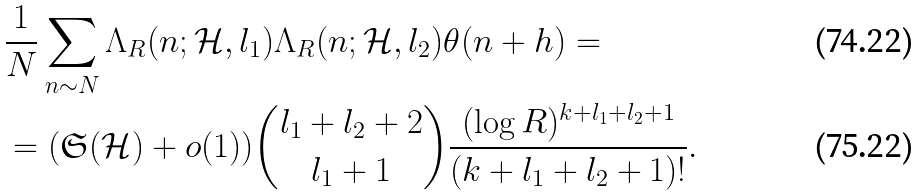<formula> <loc_0><loc_0><loc_500><loc_500>& \frac { 1 } { N } \sum _ { n \sim N } \Lambda _ { R } ( n ; \mathcal { H } , l _ { 1 } ) \Lambda _ { R } ( n ; \mathcal { H } , l _ { 2 } ) \theta ( n + h ) = \\ & = ( \mathfrak S ( \mathcal { H } ) + o ( 1 ) ) { l _ { 1 } + l _ { 2 } + 2 \choose l _ { 1 } + 1 } \frac { ( \log R ) ^ { k + l _ { 1 } + l _ { 2 } + 1 } } { ( k + l _ { 1 } + l _ { 2 } + 1 ) ! } .</formula> 